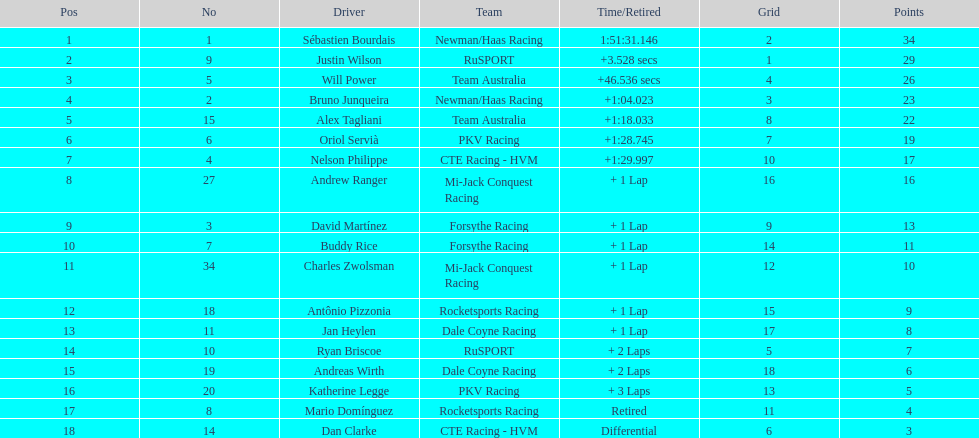How many laps did oriol servia complete at the 2006 gran premio? 66. How many laps did katherine legge complete at the 2006 gran premio? 63. Between servia and legge, who completed more laps? Oriol Servià. 